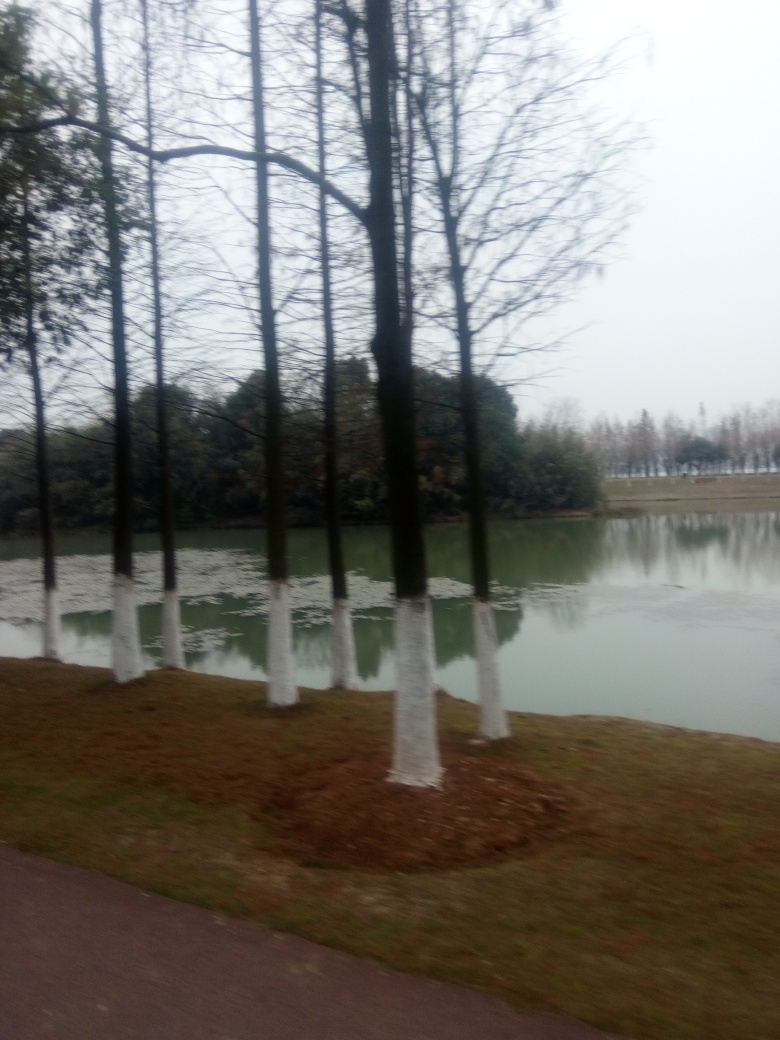Can you tell me about the treatment done to the trees? The trees in the image have their trunks painted, which is a common horticultural practice to prevent pests and diseases, and to protect against sunscald and frost damage. It's typically done with a white, water-based paint to reflect sunlight. 